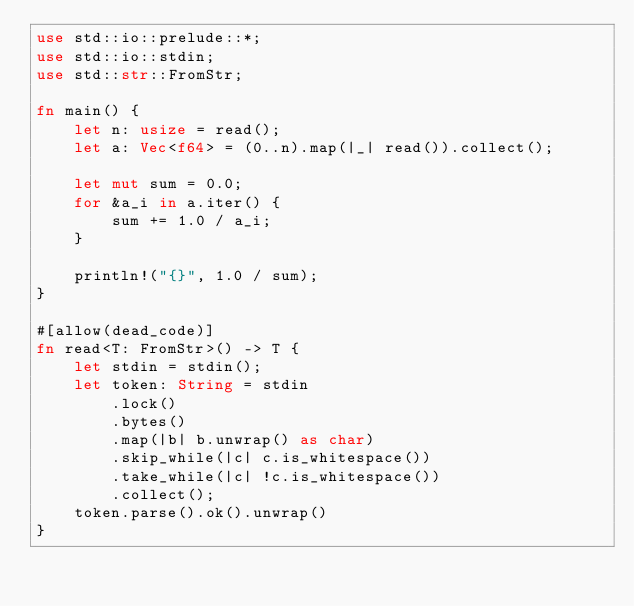<code> <loc_0><loc_0><loc_500><loc_500><_Rust_>use std::io::prelude::*;
use std::io::stdin;
use std::str::FromStr;

fn main() {
    let n: usize = read();
    let a: Vec<f64> = (0..n).map(|_| read()).collect();

    let mut sum = 0.0;
    for &a_i in a.iter() {
        sum += 1.0 / a_i;
    }

    println!("{}", 1.0 / sum);
}

#[allow(dead_code)]
fn read<T: FromStr>() -> T {
    let stdin = stdin();
    let token: String = stdin
        .lock()
        .bytes()
        .map(|b| b.unwrap() as char)
        .skip_while(|c| c.is_whitespace())
        .take_while(|c| !c.is_whitespace())
        .collect();
    token.parse().ok().unwrap()
}
</code> 